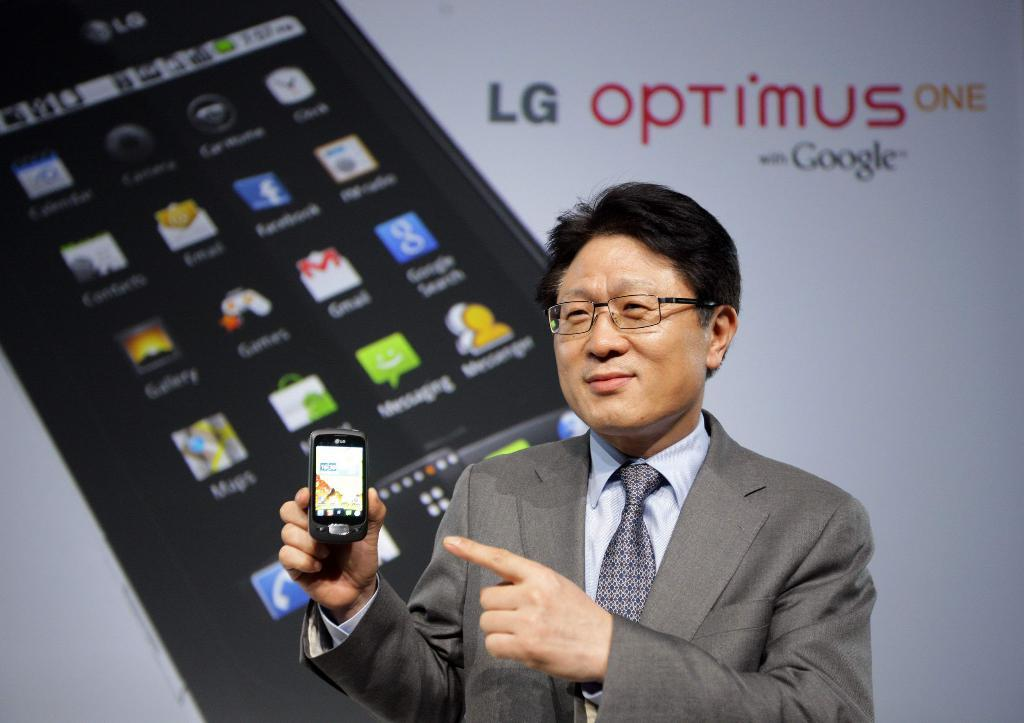<image>
Summarize the visual content of the image. A man presents a LG Optimus One phone in front of a large screen. 